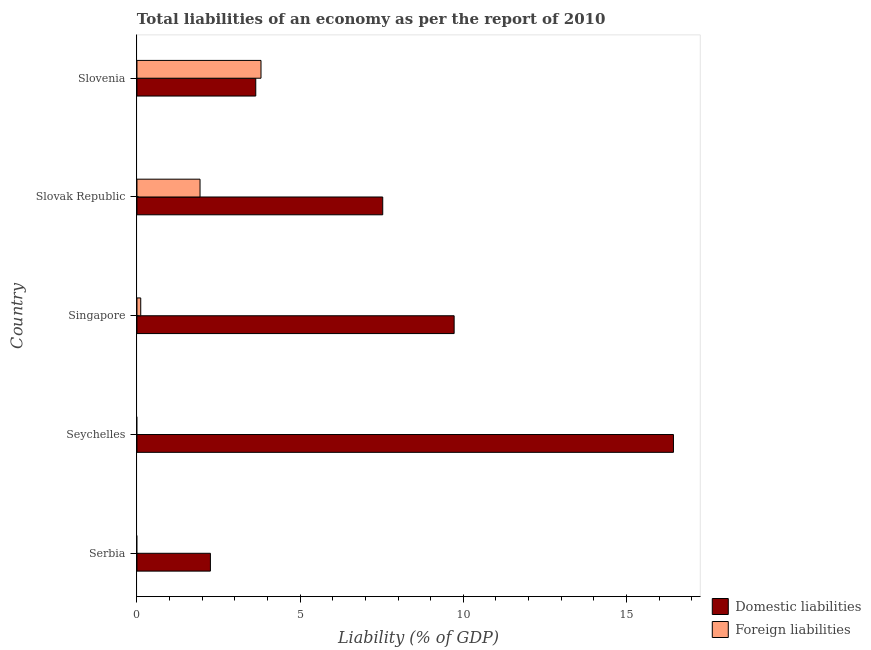How many different coloured bars are there?
Your response must be concise. 2. Are the number of bars per tick equal to the number of legend labels?
Your response must be concise. No. Are the number of bars on each tick of the Y-axis equal?
Offer a very short reply. No. How many bars are there on the 3rd tick from the top?
Provide a short and direct response. 2. How many bars are there on the 2nd tick from the bottom?
Make the answer very short. 1. What is the label of the 4th group of bars from the top?
Keep it short and to the point. Seychelles. What is the incurrence of foreign liabilities in Singapore?
Ensure brevity in your answer.  0.12. Across all countries, what is the maximum incurrence of domestic liabilities?
Offer a terse response. 16.44. In which country was the incurrence of foreign liabilities maximum?
Your response must be concise. Slovenia. What is the total incurrence of foreign liabilities in the graph?
Make the answer very short. 5.85. What is the difference between the incurrence of foreign liabilities in Slovak Republic and that in Slovenia?
Your answer should be very brief. -1.87. What is the difference between the incurrence of domestic liabilities in Slovak Republic and the incurrence of foreign liabilities in Slovenia?
Your answer should be very brief. 3.73. What is the average incurrence of domestic liabilities per country?
Make the answer very short. 7.92. What is the difference between the incurrence of foreign liabilities and incurrence of domestic liabilities in Slovak Republic?
Keep it short and to the point. -5.6. In how many countries, is the incurrence of domestic liabilities greater than 9 %?
Your answer should be very brief. 2. What is the ratio of the incurrence of domestic liabilities in Serbia to that in Singapore?
Your response must be concise. 0.23. Is the difference between the incurrence of foreign liabilities in Singapore and Slovak Republic greater than the difference between the incurrence of domestic liabilities in Singapore and Slovak Republic?
Provide a short and direct response. No. What is the difference between the highest and the second highest incurrence of domestic liabilities?
Make the answer very short. 6.72. Is the sum of the incurrence of domestic liabilities in Serbia and Slovenia greater than the maximum incurrence of foreign liabilities across all countries?
Offer a terse response. Yes. What is the difference between two consecutive major ticks on the X-axis?
Your answer should be very brief. 5. Are the values on the major ticks of X-axis written in scientific E-notation?
Make the answer very short. No. Does the graph contain grids?
Your answer should be very brief. No. Where does the legend appear in the graph?
Provide a succinct answer. Bottom right. How many legend labels are there?
Ensure brevity in your answer.  2. What is the title of the graph?
Your response must be concise. Total liabilities of an economy as per the report of 2010. Does "Number of departures" appear as one of the legend labels in the graph?
Give a very brief answer. No. What is the label or title of the X-axis?
Offer a terse response. Liability (% of GDP). What is the Liability (% of GDP) of Domestic liabilities in Serbia?
Provide a short and direct response. 2.25. What is the Liability (% of GDP) in Foreign liabilities in Serbia?
Your response must be concise. 0. What is the Liability (% of GDP) of Domestic liabilities in Seychelles?
Ensure brevity in your answer.  16.44. What is the Liability (% of GDP) of Foreign liabilities in Seychelles?
Offer a terse response. 0. What is the Liability (% of GDP) in Domestic liabilities in Singapore?
Make the answer very short. 9.72. What is the Liability (% of GDP) of Foreign liabilities in Singapore?
Your answer should be compact. 0.12. What is the Liability (% of GDP) of Domestic liabilities in Slovak Republic?
Offer a terse response. 7.53. What is the Liability (% of GDP) in Foreign liabilities in Slovak Republic?
Offer a very short reply. 1.93. What is the Liability (% of GDP) in Domestic liabilities in Slovenia?
Make the answer very short. 3.64. What is the Liability (% of GDP) in Foreign liabilities in Slovenia?
Provide a succinct answer. 3.8. Across all countries, what is the maximum Liability (% of GDP) in Domestic liabilities?
Offer a very short reply. 16.44. Across all countries, what is the maximum Liability (% of GDP) of Foreign liabilities?
Your answer should be compact. 3.8. Across all countries, what is the minimum Liability (% of GDP) of Domestic liabilities?
Your answer should be compact. 2.25. Across all countries, what is the minimum Liability (% of GDP) in Foreign liabilities?
Your answer should be very brief. 0. What is the total Liability (% of GDP) of Domestic liabilities in the graph?
Ensure brevity in your answer.  39.58. What is the total Liability (% of GDP) of Foreign liabilities in the graph?
Your response must be concise. 5.85. What is the difference between the Liability (% of GDP) of Domestic liabilities in Serbia and that in Seychelles?
Ensure brevity in your answer.  -14.19. What is the difference between the Liability (% of GDP) in Domestic liabilities in Serbia and that in Singapore?
Keep it short and to the point. -7.47. What is the difference between the Liability (% of GDP) in Domestic liabilities in Serbia and that in Slovak Republic?
Your response must be concise. -5.28. What is the difference between the Liability (% of GDP) of Domestic liabilities in Serbia and that in Slovenia?
Your response must be concise. -1.39. What is the difference between the Liability (% of GDP) in Domestic liabilities in Seychelles and that in Singapore?
Your response must be concise. 6.72. What is the difference between the Liability (% of GDP) of Domestic liabilities in Seychelles and that in Slovak Republic?
Provide a succinct answer. 8.91. What is the difference between the Liability (% of GDP) in Domestic liabilities in Seychelles and that in Slovenia?
Your response must be concise. 12.8. What is the difference between the Liability (% of GDP) in Domestic liabilities in Singapore and that in Slovak Republic?
Your response must be concise. 2.19. What is the difference between the Liability (% of GDP) in Foreign liabilities in Singapore and that in Slovak Republic?
Offer a terse response. -1.82. What is the difference between the Liability (% of GDP) in Domestic liabilities in Singapore and that in Slovenia?
Your answer should be compact. 6.08. What is the difference between the Liability (% of GDP) in Foreign liabilities in Singapore and that in Slovenia?
Give a very brief answer. -3.69. What is the difference between the Liability (% of GDP) in Domestic liabilities in Slovak Republic and that in Slovenia?
Your answer should be compact. 3.89. What is the difference between the Liability (% of GDP) in Foreign liabilities in Slovak Republic and that in Slovenia?
Make the answer very short. -1.87. What is the difference between the Liability (% of GDP) in Domestic liabilities in Serbia and the Liability (% of GDP) in Foreign liabilities in Singapore?
Ensure brevity in your answer.  2.13. What is the difference between the Liability (% of GDP) in Domestic liabilities in Serbia and the Liability (% of GDP) in Foreign liabilities in Slovak Republic?
Give a very brief answer. 0.32. What is the difference between the Liability (% of GDP) in Domestic liabilities in Serbia and the Liability (% of GDP) in Foreign liabilities in Slovenia?
Provide a succinct answer. -1.55. What is the difference between the Liability (% of GDP) of Domestic liabilities in Seychelles and the Liability (% of GDP) of Foreign liabilities in Singapore?
Provide a succinct answer. 16.32. What is the difference between the Liability (% of GDP) of Domestic liabilities in Seychelles and the Liability (% of GDP) of Foreign liabilities in Slovak Republic?
Keep it short and to the point. 14.51. What is the difference between the Liability (% of GDP) in Domestic liabilities in Seychelles and the Liability (% of GDP) in Foreign liabilities in Slovenia?
Keep it short and to the point. 12.64. What is the difference between the Liability (% of GDP) in Domestic liabilities in Singapore and the Liability (% of GDP) in Foreign liabilities in Slovak Republic?
Ensure brevity in your answer.  7.79. What is the difference between the Liability (% of GDP) of Domestic liabilities in Singapore and the Liability (% of GDP) of Foreign liabilities in Slovenia?
Offer a terse response. 5.92. What is the difference between the Liability (% of GDP) of Domestic liabilities in Slovak Republic and the Liability (% of GDP) of Foreign liabilities in Slovenia?
Keep it short and to the point. 3.73. What is the average Liability (% of GDP) in Domestic liabilities per country?
Give a very brief answer. 7.92. What is the average Liability (% of GDP) of Foreign liabilities per country?
Provide a short and direct response. 1.17. What is the difference between the Liability (% of GDP) in Domestic liabilities and Liability (% of GDP) in Foreign liabilities in Singapore?
Provide a short and direct response. 9.6. What is the difference between the Liability (% of GDP) of Domestic liabilities and Liability (% of GDP) of Foreign liabilities in Slovak Republic?
Ensure brevity in your answer.  5.6. What is the difference between the Liability (% of GDP) of Domestic liabilities and Liability (% of GDP) of Foreign liabilities in Slovenia?
Offer a very short reply. -0.16. What is the ratio of the Liability (% of GDP) of Domestic liabilities in Serbia to that in Seychelles?
Your response must be concise. 0.14. What is the ratio of the Liability (% of GDP) of Domestic liabilities in Serbia to that in Singapore?
Your answer should be very brief. 0.23. What is the ratio of the Liability (% of GDP) in Domestic liabilities in Serbia to that in Slovak Republic?
Your answer should be compact. 0.3. What is the ratio of the Liability (% of GDP) in Domestic liabilities in Serbia to that in Slovenia?
Provide a short and direct response. 0.62. What is the ratio of the Liability (% of GDP) of Domestic liabilities in Seychelles to that in Singapore?
Offer a very short reply. 1.69. What is the ratio of the Liability (% of GDP) of Domestic liabilities in Seychelles to that in Slovak Republic?
Make the answer very short. 2.18. What is the ratio of the Liability (% of GDP) in Domestic liabilities in Seychelles to that in Slovenia?
Offer a terse response. 4.52. What is the ratio of the Liability (% of GDP) of Domestic liabilities in Singapore to that in Slovak Republic?
Offer a very short reply. 1.29. What is the ratio of the Liability (% of GDP) in Foreign liabilities in Singapore to that in Slovak Republic?
Your response must be concise. 0.06. What is the ratio of the Liability (% of GDP) in Domestic liabilities in Singapore to that in Slovenia?
Offer a terse response. 2.67. What is the ratio of the Liability (% of GDP) of Foreign liabilities in Singapore to that in Slovenia?
Give a very brief answer. 0.03. What is the ratio of the Liability (% of GDP) of Domestic liabilities in Slovak Republic to that in Slovenia?
Your answer should be compact. 2.07. What is the ratio of the Liability (% of GDP) of Foreign liabilities in Slovak Republic to that in Slovenia?
Your response must be concise. 0.51. What is the difference between the highest and the second highest Liability (% of GDP) in Domestic liabilities?
Ensure brevity in your answer.  6.72. What is the difference between the highest and the second highest Liability (% of GDP) in Foreign liabilities?
Your answer should be very brief. 1.87. What is the difference between the highest and the lowest Liability (% of GDP) in Domestic liabilities?
Provide a succinct answer. 14.19. What is the difference between the highest and the lowest Liability (% of GDP) of Foreign liabilities?
Give a very brief answer. 3.8. 